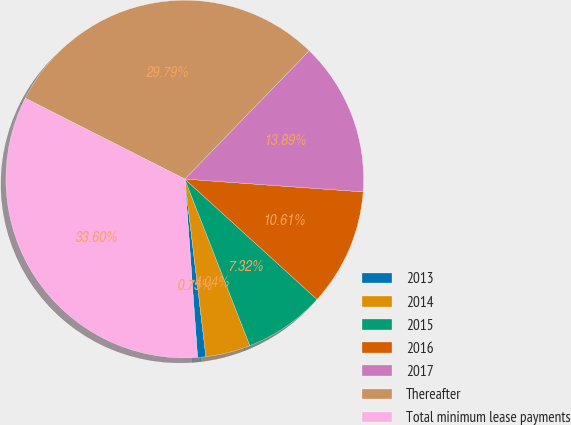Convert chart. <chart><loc_0><loc_0><loc_500><loc_500><pie_chart><fcel>2013<fcel>2014<fcel>2015<fcel>2016<fcel>2017<fcel>Thereafter<fcel>Total minimum lease payments<nl><fcel>0.75%<fcel>4.04%<fcel>7.32%<fcel>10.61%<fcel>13.89%<fcel>29.79%<fcel>33.6%<nl></chart> 